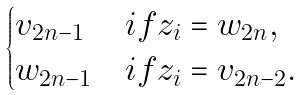Convert formula to latex. <formula><loc_0><loc_0><loc_500><loc_500>\begin{cases} v _ { 2 n - 1 } & i f z _ { i } = w _ { 2 n } , \\ w _ { 2 n - 1 } & i f z _ { i } = v _ { 2 n - 2 } . \end{cases}</formula> 